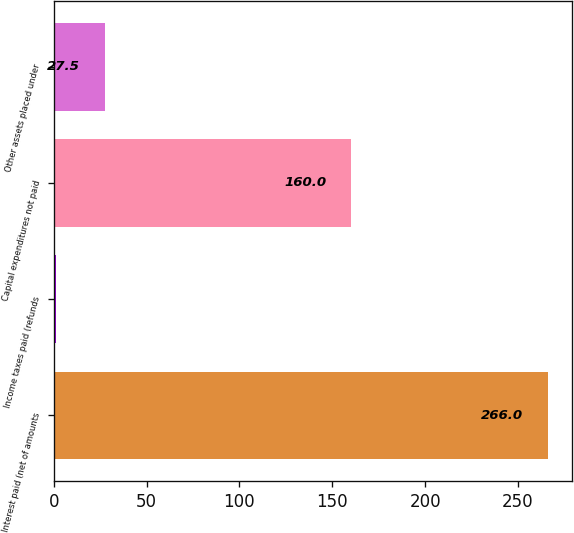Convert chart. <chart><loc_0><loc_0><loc_500><loc_500><bar_chart><fcel>Interest paid (net of amounts<fcel>Income taxes paid (refunds<fcel>Capital expenditures not paid<fcel>Other assets placed under<nl><fcel>266<fcel>1<fcel>160<fcel>27.5<nl></chart> 